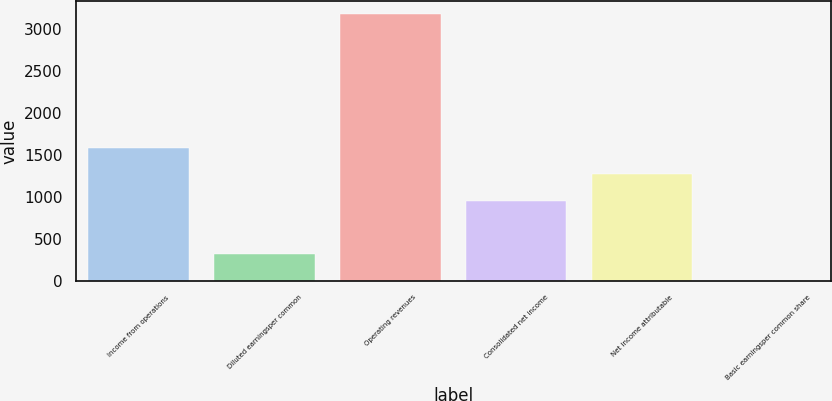Convert chart to OTSL. <chart><loc_0><loc_0><loc_500><loc_500><bar_chart><fcel>Income from operations<fcel>Diluted earningsper common<fcel>Operating revenues<fcel>Consolidated net income<fcel>Net income attributable<fcel>Basic earningsper common share<nl><fcel>1588.28<fcel>318.12<fcel>3176<fcel>953.2<fcel>1270.74<fcel>0.58<nl></chart> 